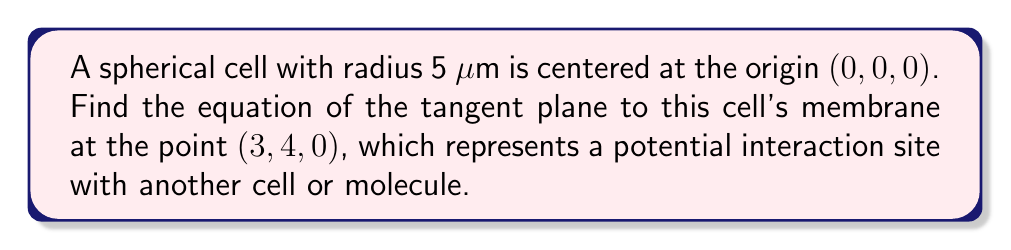Can you answer this question? 1) The general equation of a sphere centered at the origin with radius $r$ is:

   $$x^2 + y^2 + z^2 = r^2$$

2) In this case, $r = 5$, so our sphere equation is:

   $$x^2 + y^2 + z^2 = 25$$

3) The gradient of the sphere at any point $(x, y, z)$ is normal to the surface:

   $$\nabla f = (2x, 2y, 2z)$$

4) At the point of tangency $(3, 4, 0)$, the normal vector is:

   $$\vec{n} = (6, 8, 0)$$

5) The equation of a plane with normal vector $(a, b, c)$ passing through point $(x_0, y_0, z_0)$ is:

   $$a(x - x_0) + b(y - y_0) + c(z - z_0) = 0$$

6) Substituting our values:

   $$6(x - 3) + 8(y - 4) + 0(z - 0) = 0$$

7) Simplifying:

   $$6x - 18 + 8y - 32 = 0$$
   $$6x + 8y = 50$$

8) To standardize, divide by 2:

   $$3x + 4y = 25$$

This is the equation of the tangent plane, representing the local interaction surface of the cell membrane at the given point.
Answer: $3x + 4y = 25$ 